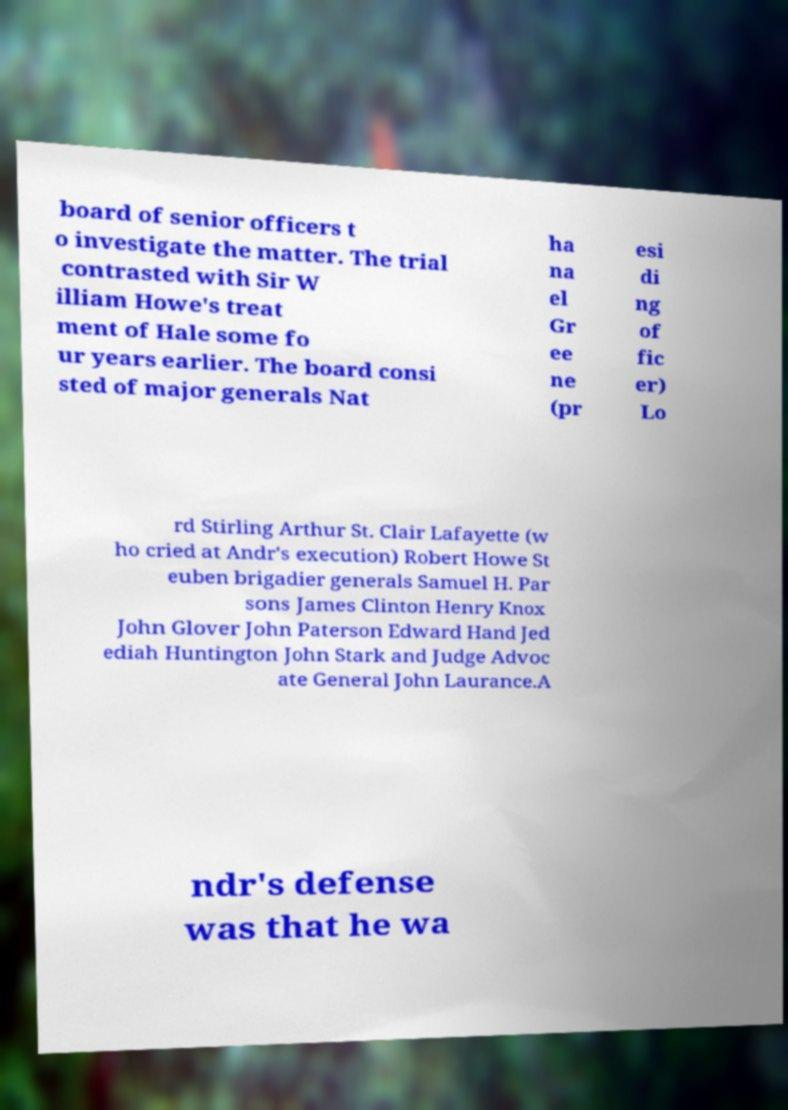Please read and relay the text visible in this image. What does it say? board of senior officers t o investigate the matter. The trial contrasted with Sir W illiam Howe's treat ment of Hale some fo ur years earlier. The board consi sted of major generals Nat ha na el Gr ee ne (pr esi di ng of fic er) Lo rd Stirling Arthur St. Clair Lafayette (w ho cried at Andr's execution) Robert Howe St euben brigadier generals Samuel H. Par sons James Clinton Henry Knox John Glover John Paterson Edward Hand Jed ediah Huntington John Stark and Judge Advoc ate General John Laurance.A ndr's defense was that he wa 